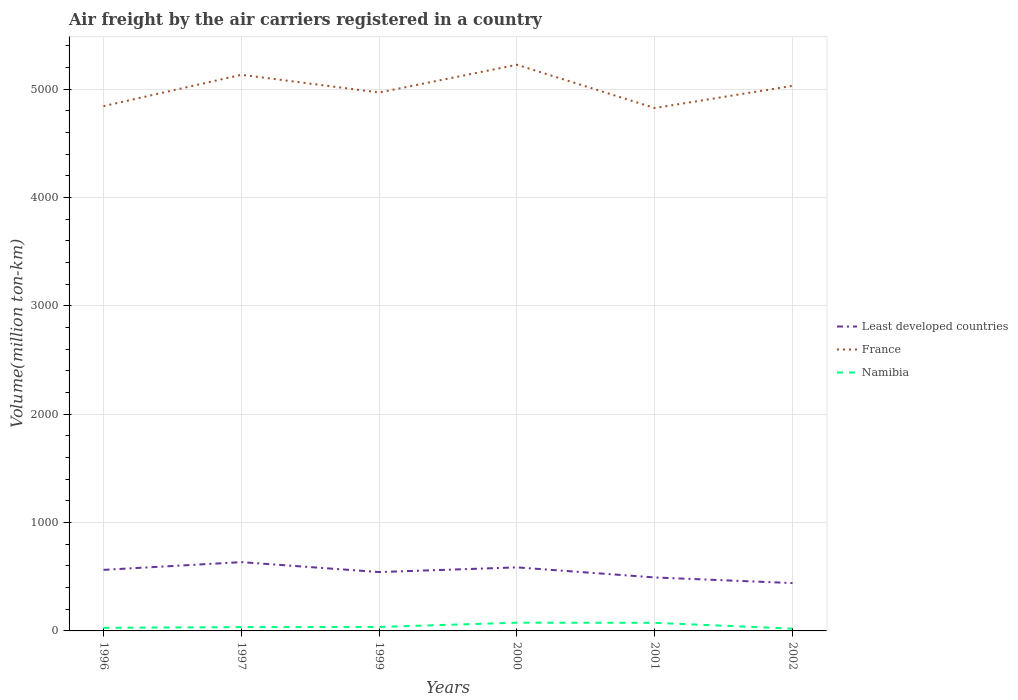How many different coloured lines are there?
Your response must be concise. 3. Across all years, what is the maximum volume of the air carriers in Namibia?
Ensure brevity in your answer.  21.06. In which year was the volume of the air carriers in Namibia maximum?
Your response must be concise. 2002. What is the total volume of the air carriers in France in the graph?
Keep it short and to the point. -204.96. What is the difference between the highest and the second highest volume of the air carriers in Least developed countries?
Ensure brevity in your answer.  193.22. How many years are there in the graph?
Offer a very short reply. 6. Are the values on the major ticks of Y-axis written in scientific E-notation?
Ensure brevity in your answer.  No. Does the graph contain grids?
Your answer should be compact. Yes. How many legend labels are there?
Your response must be concise. 3. How are the legend labels stacked?
Ensure brevity in your answer.  Vertical. What is the title of the graph?
Your answer should be compact. Air freight by the air carriers registered in a country. What is the label or title of the Y-axis?
Ensure brevity in your answer.  Volume(million ton-km). What is the Volume(million ton-km) of Least developed countries in 1996?
Your response must be concise. 563.4. What is the Volume(million ton-km) of France in 1996?
Ensure brevity in your answer.  4842.6. What is the Volume(million ton-km) in Namibia in 1996?
Offer a very short reply. 28.7. What is the Volume(million ton-km) of Least developed countries in 1997?
Give a very brief answer. 634.7. What is the Volume(million ton-km) in France in 1997?
Keep it short and to the point. 5132. What is the Volume(million ton-km) of Namibia in 1997?
Make the answer very short. 35.3. What is the Volume(million ton-km) in Least developed countries in 1999?
Offer a very short reply. 543.2. What is the Volume(million ton-km) in France in 1999?
Offer a terse response. 4968.4. What is the Volume(million ton-km) in Namibia in 1999?
Your response must be concise. 36.7. What is the Volume(million ton-km) of Least developed countries in 2000?
Make the answer very short. 586.41. What is the Volume(million ton-km) of France in 2000?
Provide a succinct answer. 5224.34. What is the Volume(million ton-km) of Namibia in 2000?
Make the answer very short. 76.01. What is the Volume(million ton-km) in Least developed countries in 2001?
Keep it short and to the point. 493.39. What is the Volume(million ton-km) in France in 2001?
Offer a terse response. 4825.2. What is the Volume(million ton-km) in Namibia in 2001?
Give a very brief answer. 74.74. What is the Volume(million ton-km) of Least developed countries in 2002?
Offer a terse response. 441.48. What is the Volume(million ton-km) in France in 2002?
Your response must be concise. 5030.16. What is the Volume(million ton-km) in Namibia in 2002?
Your response must be concise. 21.06. Across all years, what is the maximum Volume(million ton-km) of Least developed countries?
Your answer should be very brief. 634.7. Across all years, what is the maximum Volume(million ton-km) in France?
Make the answer very short. 5224.34. Across all years, what is the maximum Volume(million ton-km) of Namibia?
Your answer should be compact. 76.01. Across all years, what is the minimum Volume(million ton-km) in Least developed countries?
Provide a short and direct response. 441.48. Across all years, what is the minimum Volume(million ton-km) in France?
Offer a terse response. 4825.2. Across all years, what is the minimum Volume(million ton-km) of Namibia?
Make the answer very short. 21.06. What is the total Volume(million ton-km) in Least developed countries in the graph?
Keep it short and to the point. 3262.58. What is the total Volume(million ton-km) in France in the graph?
Your response must be concise. 3.00e+04. What is the total Volume(million ton-km) in Namibia in the graph?
Offer a terse response. 272.51. What is the difference between the Volume(million ton-km) in Least developed countries in 1996 and that in 1997?
Your answer should be compact. -71.3. What is the difference between the Volume(million ton-km) in France in 1996 and that in 1997?
Make the answer very short. -289.4. What is the difference between the Volume(million ton-km) in Least developed countries in 1996 and that in 1999?
Offer a very short reply. 20.2. What is the difference between the Volume(million ton-km) in France in 1996 and that in 1999?
Provide a short and direct response. -125.8. What is the difference between the Volume(million ton-km) of Namibia in 1996 and that in 1999?
Give a very brief answer. -8. What is the difference between the Volume(million ton-km) in Least developed countries in 1996 and that in 2000?
Provide a succinct answer. -23.01. What is the difference between the Volume(million ton-km) in France in 1996 and that in 2000?
Give a very brief answer. -381.74. What is the difference between the Volume(million ton-km) in Namibia in 1996 and that in 2000?
Ensure brevity in your answer.  -47.31. What is the difference between the Volume(million ton-km) in Least developed countries in 1996 and that in 2001?
Your answer should be compact. 70.01. What is the difference between the Volume(million ton-km) of France in 1996 and that in 2001?
Give a very brief answer. 17.4. What is the difference between the Volume(million ton-km) of Namibia in 1996 and that in 2001?
Your response must be concise. -46.04. What is the difference between the Volume(million ton-km) of Least developed countries in 1996 and that in 2002?
Your answer should be compact. 121.92. What is the difference between the Volume(million ton-km) in France in 1996 and that in 2002?
Keep it short and to the point. -187.56. What is the difference between the Volume(million ton-km) of Namibia in 1996 and that in 2002?
Provide a succinct answer. 7.64. What is the difference between the Volume(million ton-km) of Least developed countries in 1997 and that in 1999?
Provide a short and direct response. 91.5. What is the difference between the Volume(million ton-km) of France in 1997 and that in 1999?
Keep it short and to the point. 163.6. What is the difference between the Volume(million ton-km) of Least developed countries in 1997 and that in 2000?
Offer a very short reply. 48.29. What is the difference between the Volume(million ton-km) in France in 1997 and that in 2000?
Ensure brevity in your answer.  -92.34. What is the difference between the Volume(million ton-km) in Namibia in 1997 and that in 2000?
Offer a very short reply. -40.71. What is the difference between the Volume(million ton-km) in Least developed countries in 1997 and that in 2001?
Give a very brief answer. 141.31. What is the difference between the Volume(million ton-km) in France in 1997 and that in 2001?
Ensure brevity in your answer.  306.8. What is the difference between the Volume(million ton-km) of Namibia in 1997 and that in 2001?
Provide a short and direct response. -39.44. What is the difference between the Volume(million ton-km) in Least developed countries in 1997 and that in 2002?
Ensure brevity in your answer.  193.22. What is the difference between the Volume(million ton-km) of France in 1997 and that in 2002?
Make the answer very short. 101.84. What is the difference between the Volume(million ton-km) of Namibia in 1997 and that in 2002?
Your answer should be very brief. 14.24. What is the difference between the Volume(million ton-km) of Least developed countries in 1999 and that in 2000?
Give a very brief answer. -43.21. What is the difference between the Volume(million ton-km) in France in 1999 and that in 2000?
Provide a short and direct response. -255.94. What is the difference between the Volume(million ton-km) of Namibia in 1999 and that in 2000?
Give a very brief answer. -39.31. What is the difference between the Volume(million ton-km) of Least developed countries in 1999 and that in 2001?
Provide a succinct answer. 49.81. What is the difference between the Volume(million ton-km) of France in 1999 and that in 2001?
Your answer should be very brief. 143.2. What is the difference between the Volume(million ton-km) of Namibia in 1999 and that in 2001?
Your response must be concise. -38.04. What is the difference between the Volume(million ton-km) in Least developed countries in 1999 and that in 2002?
Your response must be concise. 101.72. What is the difference between the Volume(million ton-km) of France in 1999 and that in 2002?
Your response must be concise. -61.76. What is the difference between the Volume(million ton-km) in Namibia in 1999 and that in 2002?
Your answer should be compact. 15.64. What is the difference between the Volume(million ton-km) in Least developed countries in 2000 and that in 2001?
Ensure brevity in your answer.  93.02. What is the difference between the Volume(million ton-km) of France in 2000 and that in 2001?
Your answer should be compact. 399.14. What is the difference between the Volume(million ton-km) of Namibia in 2000 and that in 2001?
Provide a succinct answer. 1.26. What is the difference between the Volume(million ton-km) in Least developed countries in 2000 and that in 2002?
Provide a short and direct response. 144.92. What is the difference between the Volume(million ton-km) of France in 2000 and that in 2002?
Keep it short and to the point. 194.18. What is the difference between the Volume(million ton-km) of Namibia in 2000 and that in 2002?
Your response must be concise. 54.95. What is the difference between the Volume(million ton-km) in Least developed countries in 2001 and that in 2002?
Offer a terse response. 51.91. What is the difference between the Volume(million ton-km) in France in 2001 and that in 2002?
Provide a short and direct response. -204.96. What is the difference between the Volume(million ton-km) in Namibia in 2001 and that in 2002?
Make the answer very short. 53.69. What is the difference between the Volume(million ton-km) of Least developed countries in 1996 and the Volume(million ton-km) of France in 1997?
Make the answer very short. -4568.6. What is the difference between the Volume(million ton-km) of Least developed countries in 1996 and the Volume(million ton-km) of Namibia in 1997?
Ensure brevity in your answer.  528.1. What is the difference between the Volume(million ton-km) in France in 1996 and the Volume(million ton-km) in Namibia in 1997?
Give a very brief answer. 4807.3. What is the difference between the Volume(million ton-km) in Least developed countries in 1996 and the Volume(million ton-km) in France in 1999?
Offer a terse response. -4405. What is the difference between the Volume(million ton-km) in Least developed countries in 1996 and the Volume(million ton-km) in Namibia in 1999?
Provide a short and direct response. 526.7. What is the difference between the Volume(million ton-km) in France in 1996 and the Volume(million ton-km) in Namibia in 1999?
Give a very brief answer. 4805.9. What is the difference between the Volume(million ton-km) of Least developed countries in 1996 and the Volume(million ton-km) of France in 2000?
Offer a very short reply. -4660.94. What is the difference between the Volume(million ton-km) in Least developed countries in 1996 and the Volume(million ton-km) in Namibia in 2000?
Your response must be concise. 487.39. What is the difference between the Volume(million ton-km) in France in 1996 and the Volume(million ton-km) in Namibia in 2000?
Offer a terse response. 4766.59. What is the difference between the Volume(million ton-km) of Least developed countries in 1996 and the Volume(million ton-km) of France in 2001?
Your response must be concise. -4261.8. What is the difference between the Volume(million ton-km) of Least developed countries in 1996 and the Volume(million ton-km) of Namibia in 2001?
Make the answer very short. 488.66. What is the difference between the Volume(million ton-km) in France in 1996 and the Volume(million ton-km) in Namibia in 2001?
Offer a terse response. 4767.86. What is the difference between the Volume(million ton-km) in Least developed countries in 1996 and the Volume(million ton-km) in France in 2002?
Offer a very short reply. -4466.76. What is the difference between the Volume(million ton-km) of Least developed countries in 1996 and the Volume(million ton-km) of Namibia in 2002?
Provide a short and direct response. 542.34. What is the difference between the Volume(million ton-km) in France in 1996 and the Volume(million ton-km) in Namibia in 2002?
Your response must be concise. 4821.54. What is the difference between the Volume(million ton-km) of Least developed countries in 1997 and the Volume(million ton-km) of France in 1999?
Make the answer very short. -4333.7. What is the difference between the Volume(million ton-km) of Least developed countries in 1997 and the Volume(million ton-km) of Namibia in 1999?
Keep it short and to the point. 598. What is the difference between the Volume(million ton-km) in France in 1997 and the Volume(million ton-km) in Namibia in 1999?
Keep it short and to the point. 5095.3. What is the difference between the Volume(million ton-km) in Least developed countries in 1997 and the Volume(million ton-km) in France in 2000?
Provide a short and direct response. -4589.64. What is the difference between the Volume(million ton-km) of Least developed countries in 1997 and the Volume(million ton-km) of Namibia in 2000?
Offer a very short reply. 558.69. What is the difference between the Volume(million ton-km) in France in 1997 and the Volume(million ton-km) in Namibia in 2000?
Offer a terse response. 5055.99. What is the difference between the Volume(million ton-km) in Least developed countries in 1997 and the Volume(million ton-km) in France in 2001?
Your response must be concise. -4190.5. What is the difference between the Volume(million ton-km) in Least developed countries in 1997 and the Volume(million ton-km) in Namibia in 2001?
Your answer should be compact. 559.96. What is the difference between the Volume(million ton-km) in France in 1997 and the Volume(million ton-km) in Namibia in 2001?
Provide a short and direct response. 5057.26. What is the difference between the Volume(million ton-km) in Least developed countries in 1997 and the Volume(million ton-km) in France in 2002?
Offer a very short reply. -4395.46. What is the difference between the Volume(million ton-km) of Least developed countries in 1997 and the Volume(million ton-km) of Namibia in 2002?
Your answer should be very brief. 613.64. What is the difference between the Volume(million ton-km) in France in 1997 and the Volume(million ton-km) in Namibia in 2002?
Make the answer very short. 5110.94. What is the difference between the Volume(million ton-km) of Least developed countries in 1999 and the Volume(million ton-km) of France in 2000?
Provide a short and direct response. -4681.14. What is the difference between the Volume(million ton-km) in Least developed countries in 1999 and the Volume(million ton-km) in Namibia in 2000?
Your response must be concise. 467.19. What is the difference between the Volume(million ton-km) of France in 1999 and the Volume(million ton-km) of Namibia in 2000?
Offer a very short reply. 4892.39. What is the difference between the Volume(million ton-km) in Least developed countries in 1999 and the Volume(million ton-km) in France in 2001?
Keep it short and to the point. -4282. What is the difference between the Volume(million ton-km) in Least developed countries in 1999 and the Volume(million ton-km) in Namibia in 2001?
Your answer should be very brief. 468.46. What is the difference between the Volume(million ton-km) of France in 1999 and the Volume(million ton-km) of Namibia in 2001?
Your answer should be compact. 4893.66. What is the difference between the Volume(million ton-km) in Least developed countries in 1999 and the Volume(million ton-km) in France in 2002?
Give a very brief answer. -4486.96. What is the difference between the Volume(million ton-km) in Least developed countries in 1999 and the Volume(million ton-km) in Namibia in 2002?
Offer a very short reply. 522.14. What is the difference between the Volume(million ton-km) in France in 1999 and the Volume(million ton-km) in Namibia in 2002?
Ensure brevity in your answer.  4947.34. What is the difference between the Volume(million ton-km) in Least developed countries in 2000 and the Volume(million ton-km) in France in 2001?
Ensure brevity in your answer.  -4238.8. What is the difference between the Volume(million ton-km) in Least developed countries in 2000 and the Volume(million ton-km) in Namibia in 2001?
Offer a very short reply. 511.66. What is the difference between the Volume(million ton-km) in France in 2000 and the Volume(million ton-km) in Namibia in 2001?
Ensure brevity in your answer.  5149.6. What is the difference between the Volume(million ton-km) in Least developed countries in 2000 and the Volume(million ton-km) in France in 2002?
Your answer should be compact. -4443.75. What is the difference between the Volume(million ton-km) in Least developed countries in 2000 and the Volume(million ton-km) in Namibia in 2002?
Your answer should be very brief. 565.35. What is the difference between the Volume(million ton-km) of France in 2000 and the Volume(million ton-km) of Namibia in 2002?
Provide a short and direct response. 5203.28. What is the difference between the Volume(million ton-km) in Least developed countries in 2001 and the Volume(million ton-km) in France in 2002?
Ensure brevity in your answer.  -4536.77. What is the difference between the Volume(million ton-km) of Least developed countries in 2001 and the Volume(million ton-km) of Namibia in 2002?
Your answer should be very brief. 472.33. What is the difference between the Volume(million ton-km) in France in 2001 and the Volume(million ton-km) in Namibia in 2002?
Offer a very short reply. 4804.14. What is the average Volume(million ton-km) of Least developed countries per year?
Your answer should be compact. 543.76. What is the average Volume(million ton-km) in France per year?
Ensure brevity in your answer.  5003.78. What is the average Volume(million ton-km) in Namibia per year?
Provide a succinct answer. 45.42. In the year 1996, what is the difference between the Volume(million ton-km) in Least developed countries and Volume(million ton-km) in France?
Offer a very short reply. -4279.2. In the year 1996, what is the difference between the Volume(million ton-km) in Least developed countries and Volume(million ton-km) in Namibia?
Your response must be concise. 534.7. In the year 1996, what is the difference between the Volume(million ton-km) of France and Volume(million ton-km) of Namibia?
Give a very brief answer. 4813.9. In the year 1997, what is the difference between the Volume(million ton-km) of Least developed countries and Volume(million ton-km) of France?
Provide a succinct answer. -4497.3. In the year 1997, what is the difference between the Volume(million ton-km) in Least developed countries and Volume(million ton-km) in Namibia?
Offer a very short reply. 599.4. In the year 1997, what is the difference between the Volume(million ton-km) of France and Volume(million ton-km) of Namibia?
Provide a short and direct response. 5096.7. In the year 1999, what is the difference between the Volume(million ton-km) in Least developed countries and Volume(million ton-km) in France?
Offer a very short reply. -4425.2. In the year 1999, what is the difference between the Volume(million ton-km) in Least developed countries and Volume(million ton-km) in Namibia?
Give a very brief answer. 506.5. In the year 1999, what is the difference between the Volume(million ton-km) in France and Volume(million ton-km) in Namibia?
Give a very brief answer. 4931.7. In the year 2000, what is the difference between the Volume(million ton-km) in Least developed countries and Volume(million ton-km) in France?
Offer a very short reply. -4637.93. In the year 2000, what is the difference between the Volume(million ton-km) of Least developed countries and Volume(million ton-km) of Namibia?
Your answer should be very brief. 510.4. In the year 2000, what is the difference between the Volume(million ton-km) of France and Volume(million ton-km) of Namibia?
Make the answer very short. 5148.33. In the year 2001, what is the difference between the Volume(million ton-km) of Least developed countries and Volume(million ton-km) of France?
Make the answer very short. -4331.81. In the year 2001, what is the difference between the Volume(million ton-km) of Least developed countries and Volume(million ton-km) of Namibia?
Provide a short and direct response. 418.65. In the year 2001, what is the difference between the Volume(million ton-km) in France and Volume(million ton-km) in Namibia?
Make the answer very short. 4750.46. In the year 2002, what is the difference between the Volume(million ton-km) in Least developed countries and Volume(million ton-km) in France?
Ensure brevity in your answer.  -4588.68. In the year 2002, what is the difference between the Volume(million ton-km) of Least developed countries and Volume(million ton-km) of Namibia?
Keep it short and to the point. 420.43. In the year 2002, what is the difference between the Volume(million ton-km) of France and Volume(million ton-km) of Namibia?
Your answer should be compact. 5009.1. What is the ratio of the Volume(million ton-km) of Least developed countries in 1996 to that in 1997?
Your answer should be compact. 0.89. What is the ratio of the Volume(million ton-km) of France in 1996 to that in 1997?
Make the answer very short. 0.94. What is the ratio of the Volume(million ton-km) in Namibia in 1996 to that in 1997?
Your answer should be compact. 0.81. What is the ratio of the Volume(million ton-km) of Least developed countries in 1996 to that in 1999?
Provide a short and direct response. 1.04. What is the ratio of the Volume(million ton-km) in France in 1996 to that in 1999?
Ensure brevity in your answer.  0.97. What is the ratio of the Volume(million ton-km) in Namibia in 1996 to that in 1999?
Your answer should be very brief. 0.78. What is the ratio of the Volume(million ton-km) in Least developed countries in 1996 to that in 2000?
Offer a terse response. 0.96. What is the ratio of the Volume(million ton-km) in France in 1996 to that in 2000?
Give a very brief answer. 0.93. What is the ratio of the Volume(million ton-km) in Namibia in 1996 to that in 2000?
Offer a terse response. 0.38. What is the ratio of the Volume(million ton-km) in Least developed countries in 1996 to that in 2001?
Make the answer very short. 1.14. What is the ratio of the Volume(million ton-km) of France in 1996 to that in 2001?
Offer a very short reply. 1. What is the ratio of the Volume(million ton-km) in Namibia in 1996 to that in 2001?
Your answer should be compact. 0.38. What is the ratio of the Volume(million ton-km) in Least developed countries in 1996 to that in 2002?
Your answer should be compact. 1.28. What is the ratio of the Volume(million ton-km) of France in 1996 to that in 2002?
Give a very brief answer. 0.96. What is the ratio of the Volume(million ton-km) in Namibia in 1996 to that in 2002?
Your answer should be very brief. 1.36. What is the ratio of the Volume(million ton-km) of Least developed countries in 1997 to that in 1999?
Make the answer very short. 1.17. What is the ratio of the Volume(million ton-km) in France in 1997 to that in 1999?
Give a very brief answer. 1.03. What is the ratio of the Volume(million ton-km) in Namibia in 1997 to that in 1999?
Provide a short and direct response. 0.96. What is the ratio of the Volume(million ton-km) of Least developed countries in 1997 to that in 2000?
Your answer should be compact. 1.08. What is the ratio of the Volume(million ton-km) in France in 1997 to that in 2000?
Provide a succinct answer. 0.98. What is the ratio of the Volume(million ton-km) of Namibia in 1997 to that in 2000?
Offer a terse response. 0.46. What is the ratio of the Volume(million ton-km) in Least developed countries in 1997 to that in 2001?
Make the answer very short. 1.29. What is the ratio of the Volume(million ton-km) of France in 1997 to that in 2001?
Provide a short and direct response. 1.06. What is the ratio of the Volume(million ton-km) of Namibia in 1997 to that in 2001?
Make the answer very short. 0.47. What is the ratio of the Volume(million ton-km) of Least developed countries in 1997 to that in 2002?
Provide a short and direct response. 1.44. What is the ratio of the Volume(million ton-km) of France in 1997 to that in 2002?
Offer a very short reply. 1.02. What is the ratio of the Volume(million ton-km) of Namibia in 1997 to that in 2002?
Keep it short and to the point. 1.68. What is the ratio of the Volume(million ton-km) of Least developed countries in 1999 to that in 2000?
Offer a very short reply. 0.93. What is the ratio of the Volume(million ton-km) in France in 1999 to that in 2000?
Your response must be concise. 0.95. What is the ratio of the Volume(million ton-km) in Namibia in 1999 to that in 2000?
Offer a terse response. 0.48. What is the ratio of the Volume(million ton-km) in Least developed countries in 1999 to that in 2001?
Offer a terse response. 1.1. What is the ratio of the Volume(million ton-km) of France in 1999 to that in 2001?
Your answer should be very brief. 1.03. What is the ratio of the Volume(million ton-km) in Namibia in 1999 to that in 2001?
Provide a succinct answer. 0.49. What is the ratio of the Volume(million ton-km) in Least developed countries in 1999 to that in 2002?
Keep it short and to the point. 1.23. What is the ratio of the Volume(million ton-km) of France in 1999 to that in 2002?
Your answer should be very brief. 0.99. What is the ratio of the Volume(million ton-km) in Namibia in 1999 to that in 2002?
Make the answer very short. 1.74. What is the ratio of the Volume(million ton-km) in Least developed countries in 2000 to that in 2001?
Give a very brief answer. 1.19. What is the ratio of the Volume(million ton-km) of France in 2000 to that in 2001?
Your answer should be compact. 1.08. What is the ratio of the Volume(million ton-km) of Namibia in 2000 to that in 2001?
Make the answer very short. 1.02. What is the ratio of the Volume(million ton-km) in Least developed countries in 2000 to that in 2002?
Provide a short and direct response. 1.33. What is the ratio of the Volume(million ton-km) of France in 2000 to that in 2002?
Provide a short and direct response. 1.04. What is the ratio of the Volume(million ton-km) in Namibia in 2000 to that in 2002?
Offer a terse response. 3.61. What is the ratio of the Volume(million ton-km) in Least developed countries in 2001 to that in 2002?
Your response must be concise. 1.12. What is the ratio of the Volume(million ton-km) in France in 2001 to that in 2002?
Give a very brief answer. 0.96. What is the ratio of the Volume(million ton-km) in Namibia in 2001 to that in 2002?
Offer a terse response. 3.55. What is the difference between the highest and the second highest Volume(million ton-km) of Least developed countries?
Offer a very short reply. 48.29. What is the difference between the highest and the second highest Volume(million ton-km) of France?
Offer a very short reply. 92.34. What is the difference between the highest and the second highest Volume(million ton-km) of Namibia?
Ensure brevity in your answer.  1.26. What is the difference between the highest and the lowest Volume(million ton-km) in Least developed countries?
Your answer should be very brief. 193.22. What is the difference between the highest and the lowest Volume(million ton-km) of France?
Provide a succinct answer. 399.14. What is the difference between the highest and the lowest Volume(million ton-km) of Namibia?
Provide a succinct answer. 54.95. 